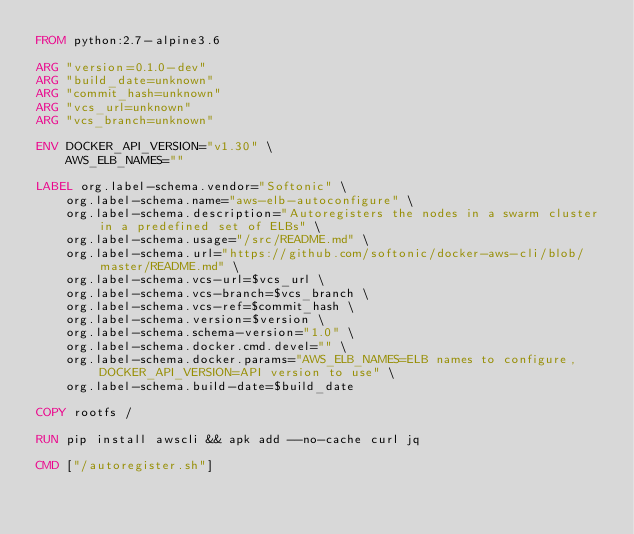<code> <loc_0><loc_0><loc_500><loc_500><_Dockerfile_>FROM python:2.7-alpine3.6

ARG "version=0.1.0-dev"
ARG "build_date=unknown"
ARG "commit_hash=unknown"
ARG "vcs_url=unknown"
ARG "vcs_branch=unknown"

ENV DOCKER_API_VERSION="v1.30" \
    AWS_ELB_NAMES=""

LABEL org.label-schema.vendor="Softonic" \
    org.label-schema.name="aws-elb-autoconfigure" \
    org.label-schema.description="Autoregisters the nodes in a swarm cluster in a predefined set of ELBs" \
    org.label-schema.usage="/src/README.md" \
    org.label-schema.url="https://github.com/softonic/docker-aws-cli/blob/master/README.md" \
    org.label-schema.vcs-url=$vcs_url \
    org.label-schema.vcs-branch=$vcs_branch \
    org.label-schema.vcs-ref=$commit_hash \
    org.label-schema.version=$version \
    org.label-schema.schema-version="1.0" \
    org.label-schema.docker.cmd.devel="" \
    org.label-schema.docker.params="AWS_ELB_NAMES=ELB names to configure,DOCKER_API_VERSION=API version to use" \
    org.label-schema.build-date=$build_date

COPY rootfs /

RUN pip install awscli && apk add --no-cache curl jq

CMD ["/autoregister.sh"]
</code> 